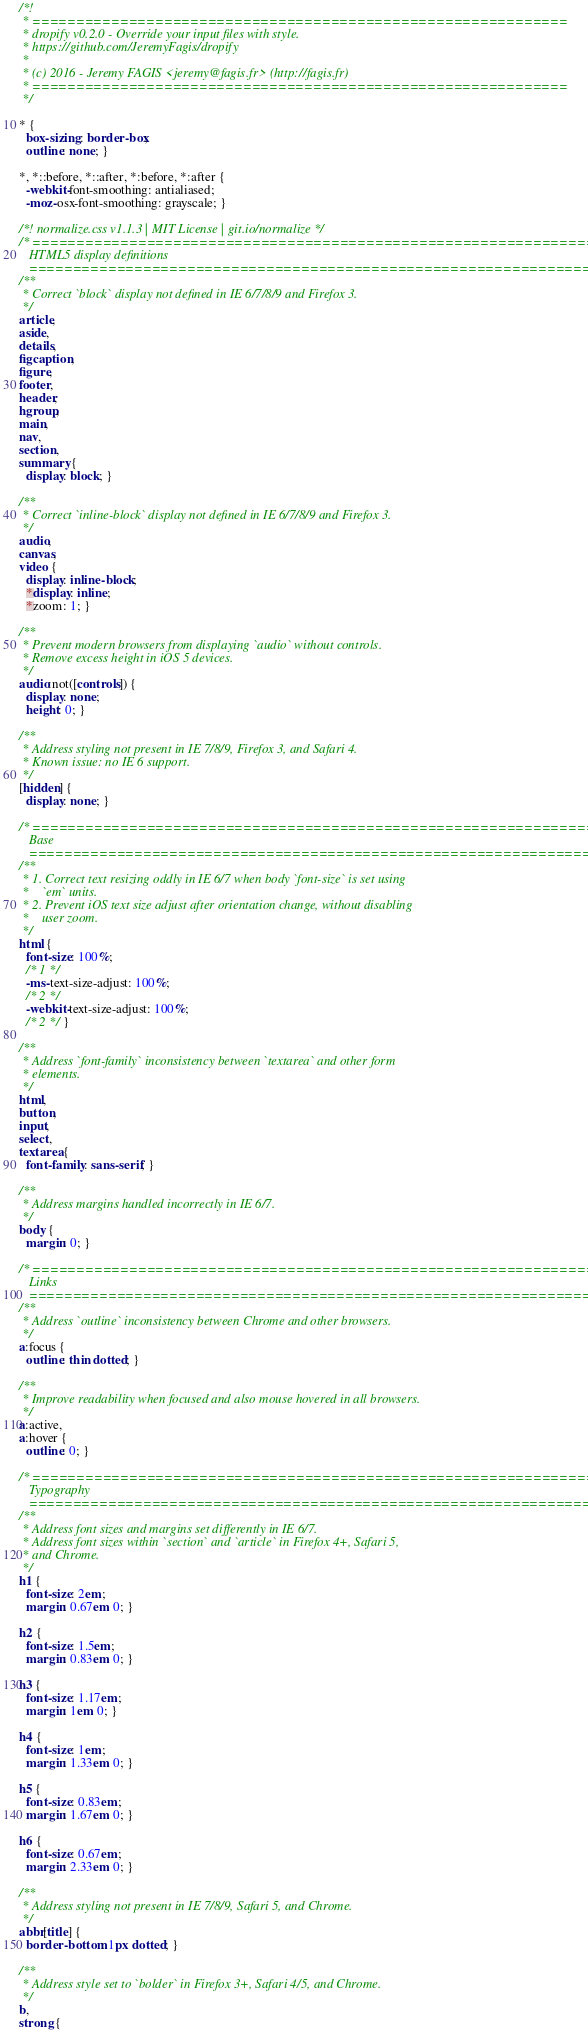Convert code to text. <code><loc_0><loc_0><loc_500><loc_500><_CSS_>/*!
 * =============================================================
 * dropify v0.2.0 - Override your input files with style.
 * https://github.com/JeremyFagis/dropify
 *
 * (c) 2016 - Jeremy FAGIS <jeremy@fagis.fr> (http://fagis.fr)
 * =============================================================
 */

* {
  box-sizing: border-box;
  outline: none; }

*, *::before, *::after, *:before, *:after {
  -webkit-font-smoothing: antialiased;
  -moz-osx-font-smoothing: grayscale; }

/*! normalize.css v1.1.3 | MIT License | git.io/normalize */
/* ==========================================================================
   HTML5 display definitions
   ========================================================================== */
/**
 * Correct `block` display not defined in IE 6/7/8/9 and Firefox 3.
 */
article,
aside,
details,
figcaption,
figure,
footer,
header,
hgroup,
main,
nav,
section,
summary {
  display: block; }

/**
 * Correct `inline-block` display not defined in IE 6/7/8/9 and Firefox 3.
 */
audio,
canvas,
video {
  display: inline-block;
  *display: inline;
  *zoom: 1; }

/**
 * Prevent modern browsers from displaying `audio` without controls.
 * Remove excess height in iOS 5 devices.
 */
audio:not([controls]) {
  display: none;
  height: 0; }

/**
 * Address styling not present in IE 7/8/9, Firefox 3, and Safari 4.
 * Known issue: no IE 6 support.
 */
[hidden] {
  display: none; }

/* ==========================================================================
   Base
   ========================================================================== */
/**
 * 1. Correct text resizing oddly in IE 6/7 when body `font-size` is set using
 *    `em` units.
 * 2. Prevent iOS text size adjust after orientation change, without disabling
 *    user zoom.
 */
html {
  font-size: 100%;
  /* 1 */
  -ms-text-size-adjust: 100%;
  /* 2 */
  -webkit-text-size-adjust: 100%;
  /* 2 */ }

/**
 * Address `font-family` inconsistency between `textarea` and other form
 * elements.
 */
html,
button,
input,
select,
textarea {
  font-family: sans-serif; }

/**
 * Address margins handled incorrectly in IE 6/7.
 */
body {
  margin: 0; }

/* ==========================================================================
   Links
   ========================================================================== */
/**
 * Address `outline` inconsistency between Chrome and other browsers.
 */
a:focus {
  outline: thin dotted; }

/**
 * Improve readability when focused and also mouse hovered in all browsers.
 */
a:active,
a:hover {
  outline: 0; }

/* ==========================================================================
   Typography
   ========================================================================== */
/**
 * Address font sizes and margins set differently in IE 6/7.
 * Address font sizes within `section` and `article` in Firefox 4+, Safari 5,
 * and Chrome.
 */
h1 {
  font-size: 2em;
  margin: 0.67em 0; }

h2 {
  font-size: 1.5em;
  margin: 0.83em 0; }

h3 {
  font-size: 1.17em;
  margin: 1em 0; }

h4 {
  font-size: 1em;
  margin: 1.33em 0; }

h5 {
  font-size: 0.83em;
  margin: 1.67em 0; }

h6 {
  font-size: 0.67em;
  margin: 2.33em 0; }

/**
 * Address styling not present in IE 7/8/9, Safari 5, and Chrome.
 */
abbr[title] {
  border-bottom: 1px dotted; }

/**
 * Address style set to `bolder` in Firefox 3+, Safari 4/5, and Chrome.
 */
b,
strong {</code> 